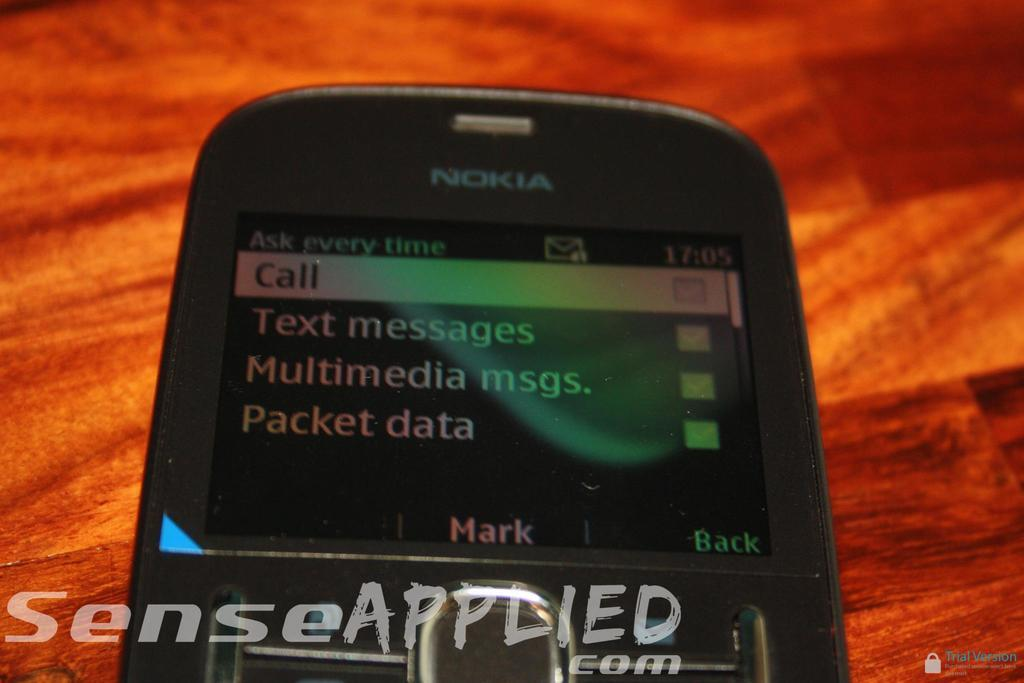Provide a one-sentence caption for the provided image. A black phone from Nokia is on a wooden table. 